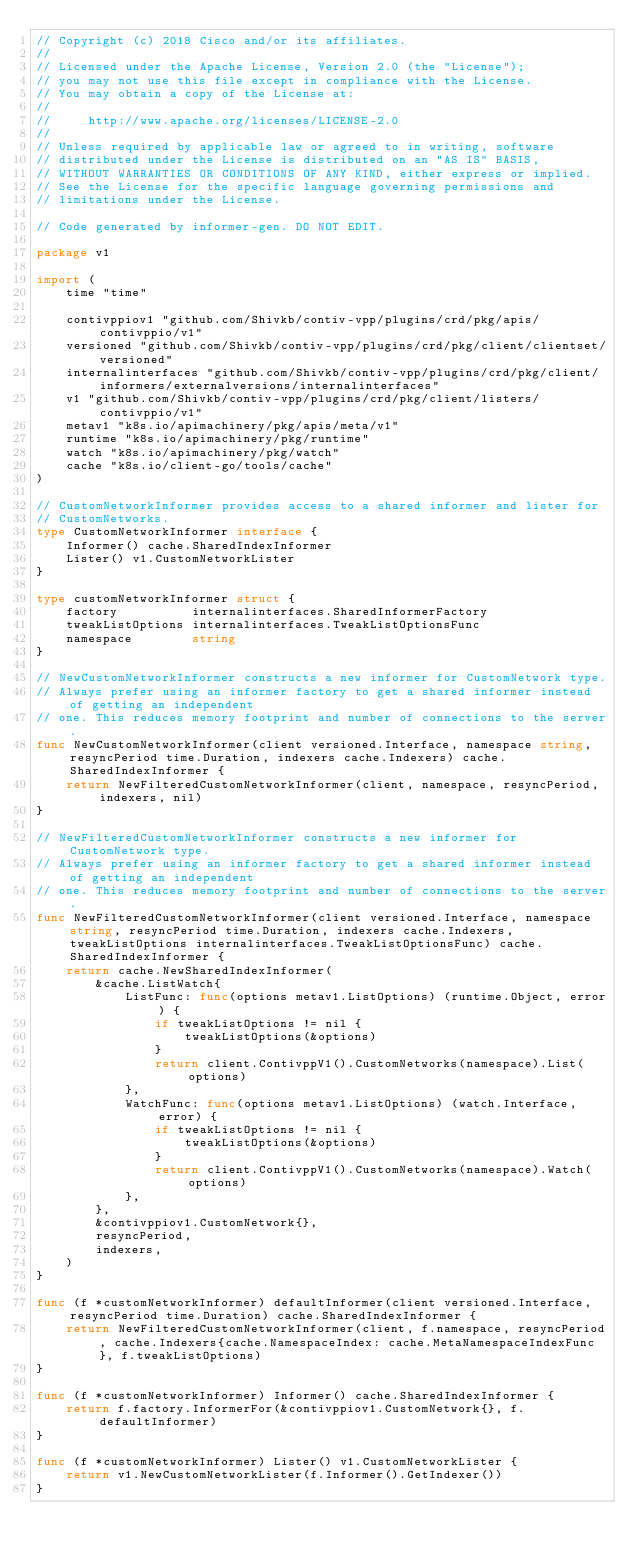<code> <loc_0><loc_0><loc_500><loc_500><_Go_>// Copyright (c) 2018 Cisco and/or its affiliates.
//
// Licensed under the Apache License, Version 2.0 (the "License");
// you may not use this file except in compliance with the License.
// You may obtain a copy of the License at:
//
//     http://www.apache.org/licenses/LICENSE-2.0
//
// Unless required by applicable law or agreed to in writing, software
// distributed under the License is distributed on an "AS IS" BASIS,
// WITHOUT WARRANTIES OR CONDITIONS OF ANY KIND, either express or implied.
// See the License for the specific language governing permissions and
// limitations under the License.

// Code generated by informer-gen. DO NOT EDIT.

package v1

import (
	time "time"

	contivppiov1 "github.com/Shivkb/contiv-vpp/plugins/crd/pkg/apis/contivppio/v1"
	versioned "github.com/Shivkb/contiv-vpp/plugins/crd/pkg/client/clientset/versioned"
	internalinterfaces "github.com/Shivkb/contiv-vpp/plugins/crd/pkg/client/informers/externalversions/internalinterfaces"
	v1 "github.com/Shivkb/contiv-vpp/plugins/crd/pkg/client/listers/contivppio/v1"
	metav1 "k8s.io/apimachinery/pkg/apis/meta/v1"
	runtime "k8s.io/apimachinery/pkg/runtime"
	watch "k8s.io/apimachinery/pkg/watch"
	cache "k8s.io/client-go/tools/cache"
)

// CustomNetworkInformer provides access to a shared informer and lister for
// CustomNetworks.
type CustomNetworkInformer interface {
	Informer() cache.SharedIndexInformer
	Lister() v1.CustomNetworkLister
}

type customNetworkInformer struct {
	factory          internalinterfaces.SharedInformerFactory
	tweakListOptions internalinterfaces.TweakListOptionsFunc
	namespace        string
}

// NewCustomNetworkInformer constructs a new informer for CustomNetwork type.
// Always prefer using an informer factory to get a shared informer instead of getting an independent
// one. This reduces memory footprint and number of connections to the server.
func NewCustomNetworkInformer(client versioned.Interface, namespace string, resyncPeriod time.Duration, indexers cache.Indexers) cache.SharedIndexInformer {
	return NewFilteredCustomNetworkInformer(client, namespace, resyncPeriod, indexers, nil)
}

// NewFilteredCustomNetworkInformer constructs a new informer for CustomNetwork type.
// Always prefer using an informer factory to get a shared informer instead of getting an independent
// one. This reduces memory footprint and number of connections to the server.
func NewFilteredCustomNetworkInformer(client versioned.Interface, namespace string, resyncPeriod time.Duration, indexers cache.Indexers, tweakListOptions internalinterfaces.TweakListOptionsFunc) cache.SharedIndexInformer {
	return cache.NewSharedIndexInformer(
		&cache.ListWatch{
			ListFunc: func(options metav1.ListOptions) (runtime.Object, error) {
				if tweakListOptions != nil {
					tweakListOptions(&options)
				}
				return client.ContivppV1().CustomNetworks(namespace).List(options)
			},
			WatchFunc: func(options metav1.ListOptions) (watch.Interface, error) {
				if tweakListOptions != nil {
					tweakListOptions(&options)
				}
				return client.ContivppV1().CustomNetworks(namespace).Watch(options)
			},
		},
		&contivppiov1.CustomNetwork{},
		resyncPeriod,
		indexers,
	)
}

func (f *customNetworkInformer) defaultInformer(client versioned.Interface, resyncPeriod time.Duration) cache.SharedIndexInformer {
	return NewFilteredCustomNetworkInformer(client, f.namespace, resyncPeriod, cache.Indexers{cache.NamespaceIndex: cache.MetaNamespaceIndexFunc}, f.tweakListOptions)
}

func (f *customNetworkInformer) Informer() cache.SharedIndexInformer {
	return f.factory.InformerFor(&contivppiov1.CustomNetwork{}, f.defaultInformer)
}

func (f *customNetworkInformer) Lister() v1.CustomNetworkLister {
	return v1.NewCustomNetworkLister(f.Informer().GetIndexer())
}
</code> 